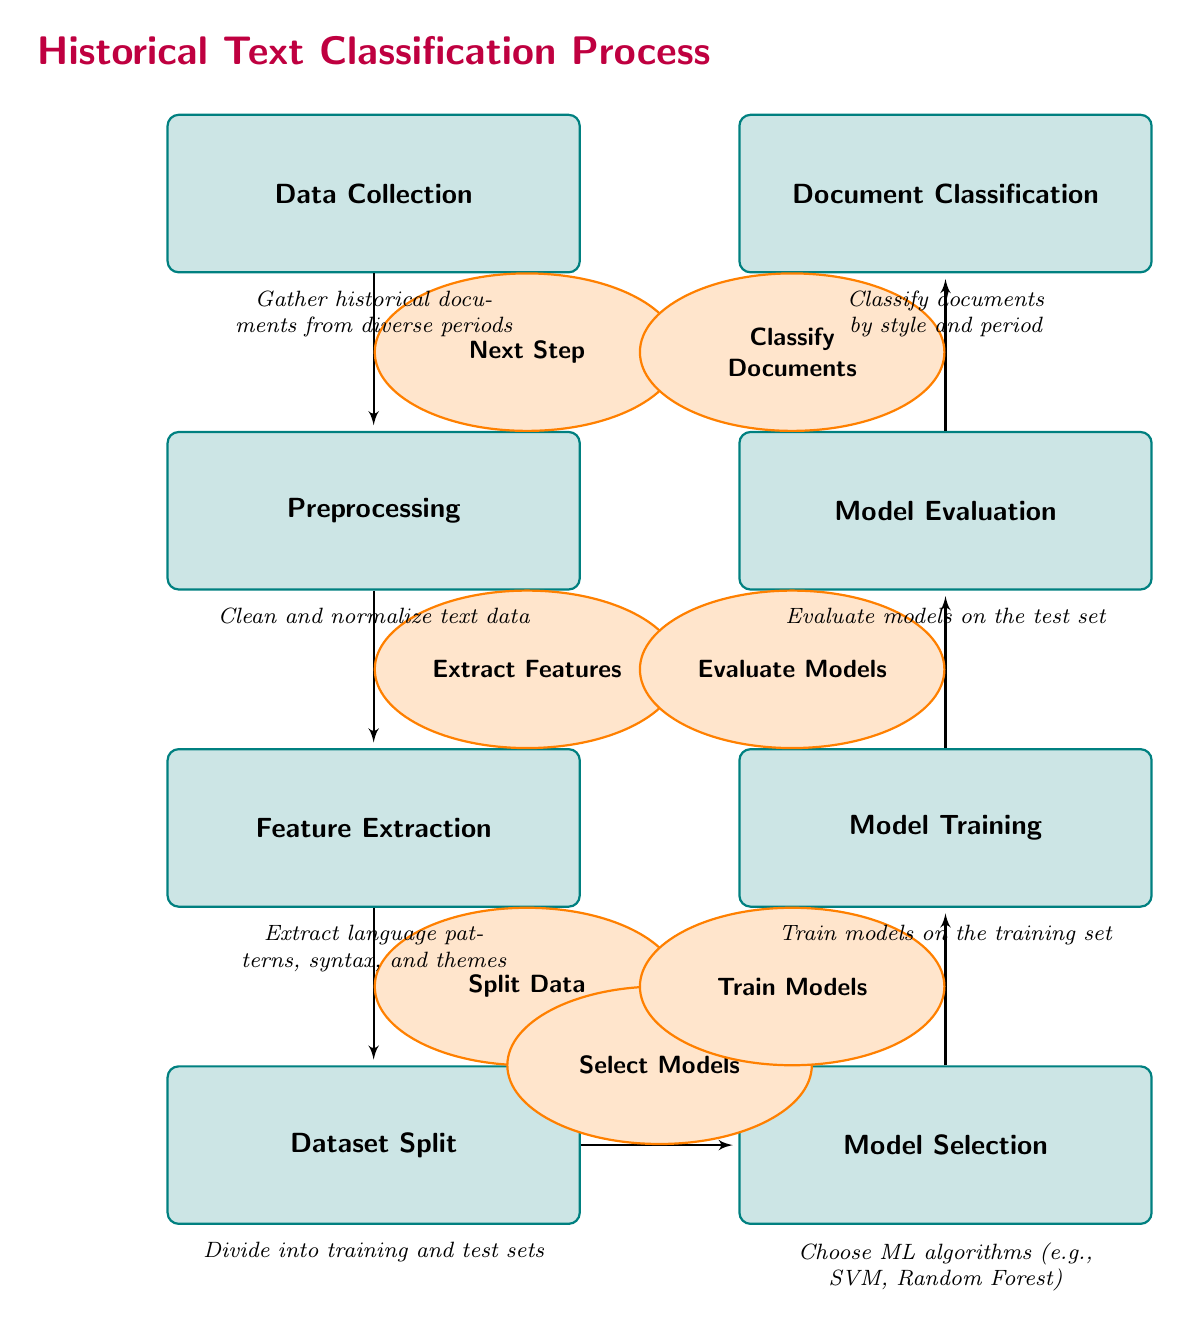What is the first step in the diagram? The first step is labeled as "Data Collection," which is located at the top of the flow.
Answer: Data Collection How many nodes are present in the diagram? Counting each of the labeled blocks and the title, there are seven nodes in total.
Answer: Seven What comes after the "Preprocessing" step? The step that directly follows "Preprocessing" is "Feature Extraction," as indicated by the arrow leading down.
Answer: Feature Extraction What type of machine learning algorithms might be selected in the "Model Selection" step? The label suggests selecting machine learning algorithms such as Support Vector Machine and Random Forest, which are mentioned in the description of the node.
Answer: Support Vector Machine, Random Forest Which step evaluates the models? The step that performs this function is labeled as "Model Evaluation," which is positioned directly above the "Document Classification" step.
Answer: Model Evaluation What is the output of the "Model Evaluation" step? The output is the classification of documents by style and period, as indicated in the flow leading to the final node "Document Classification."
Answer: Classify Documents How are the data sets divided in the diagram? The dataset is divided into training and test sets during the "Dataset Split" step, which is specifically described in the diagram.
Answer: Training and test sets Which step involves extracting specific characteristics from the documents? The step focused on extracting these features is labeled "Feature Extraction," and it emphasizes language patterns and syntax.
Answer: Feature Extraction What is the last step in the process? The last step in the diagram is labeled "Document Classification," which comes after all the model-related steps have been completed.
Answer: Document Classification 